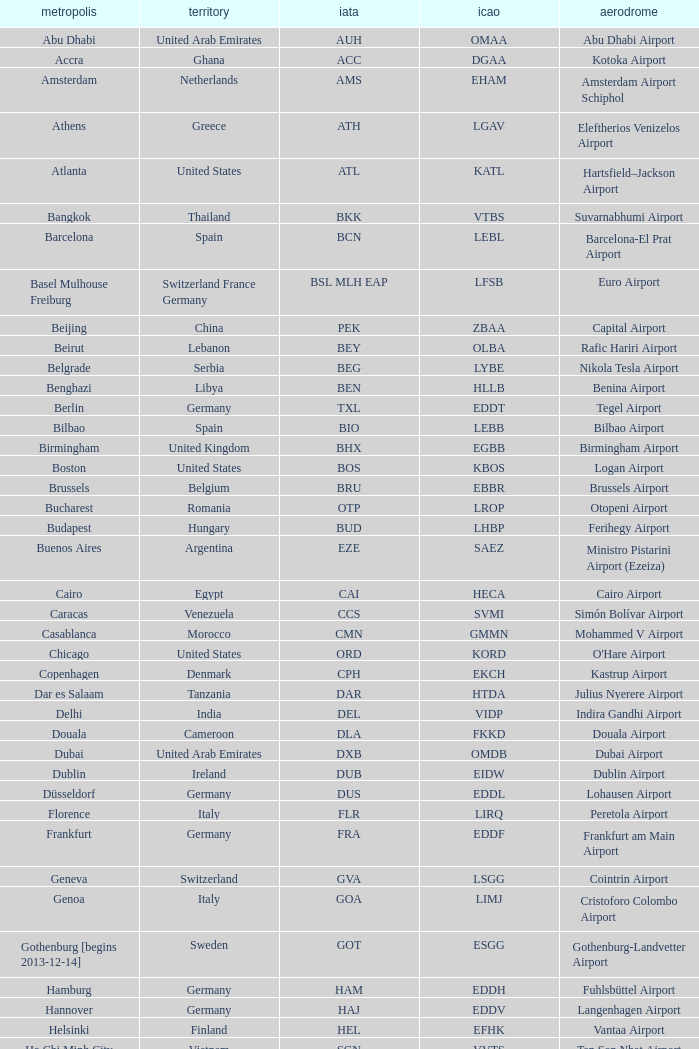What is the IATA of galeão airport? GIG. 